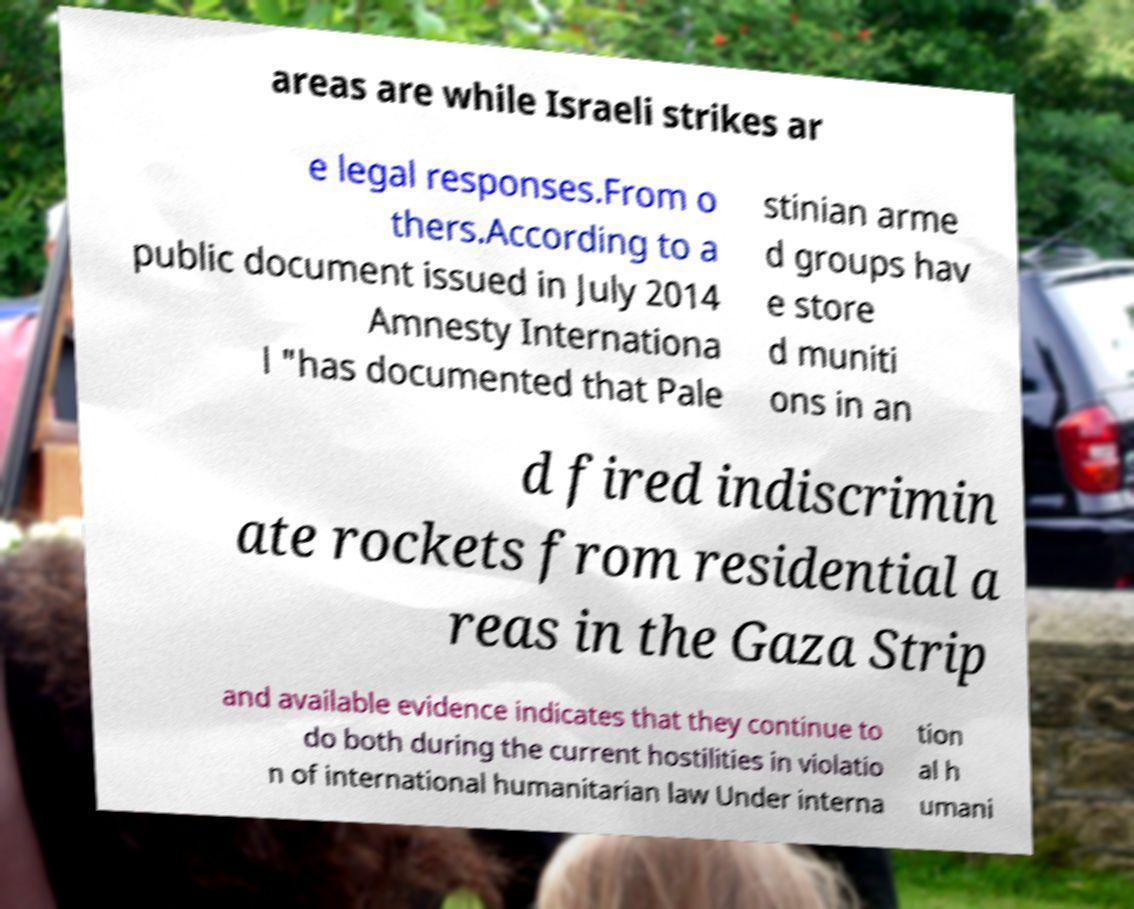For documentation purposes, I need the text within this image transcribed. Could you provide that? areas are while Israeli strikes ar e legal responses.From o thers.According to a public document issued in July 2014 Amnesty Internationa l "has documented that Pale stinian arme d groups hav e store d muniti ons in an d fired indiscrimin ate rockets from residential a reas in the Gaza Strip and available evidence indicates that they continue to do both during the current hostilities in violatio n of international humanitarian law Under interna tion al h umani 